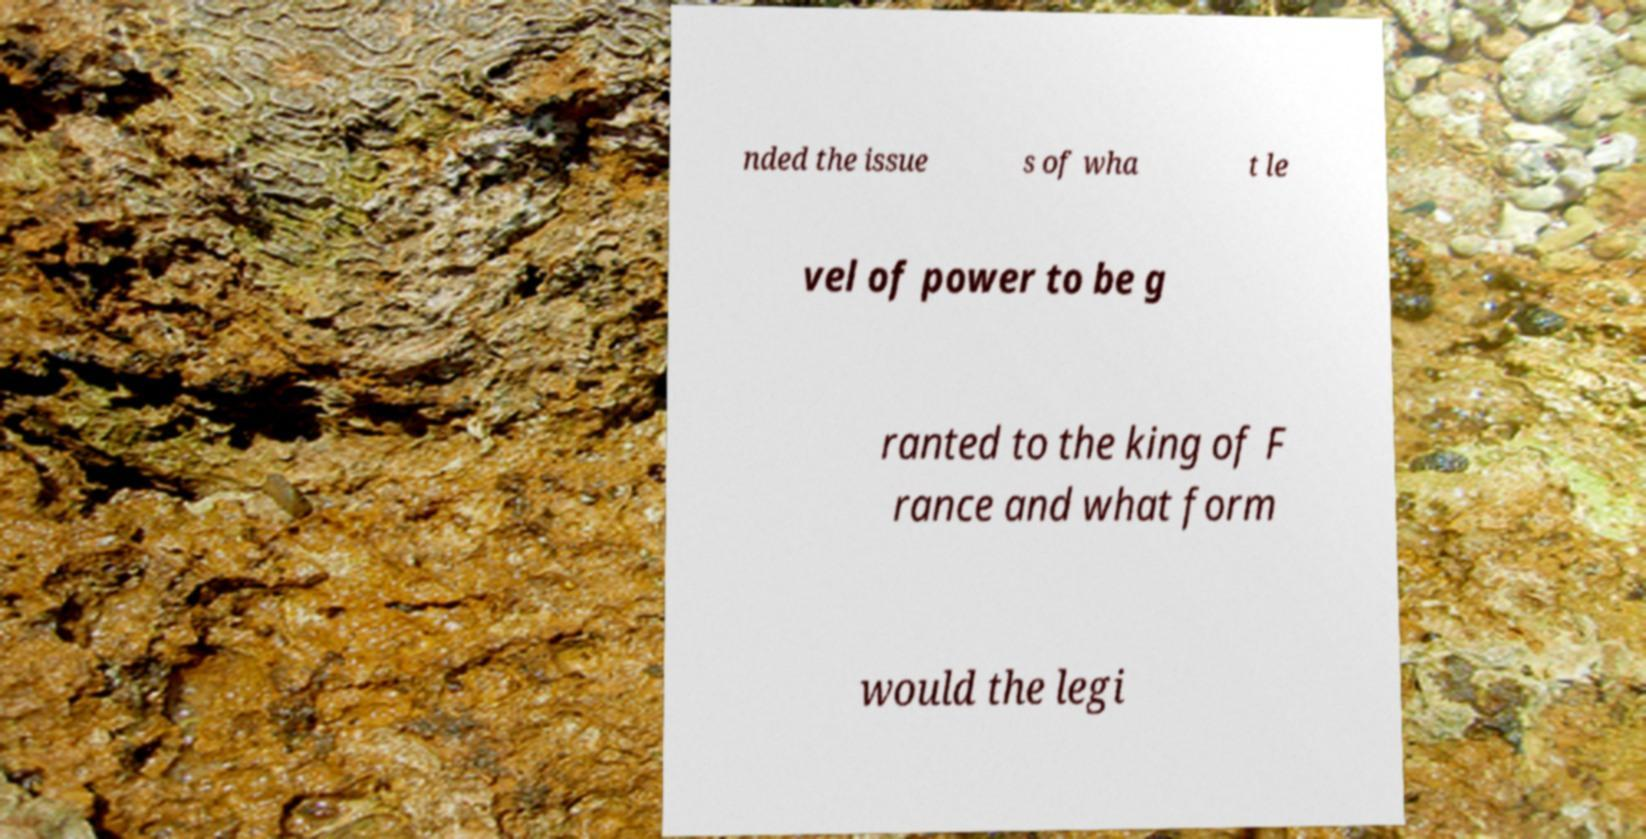What messages or text are displayed in this image? I need them in a readable, typed format. nded the issue s of wha t le vel of power to be g ranted to the king of F rance and what form would the legi 